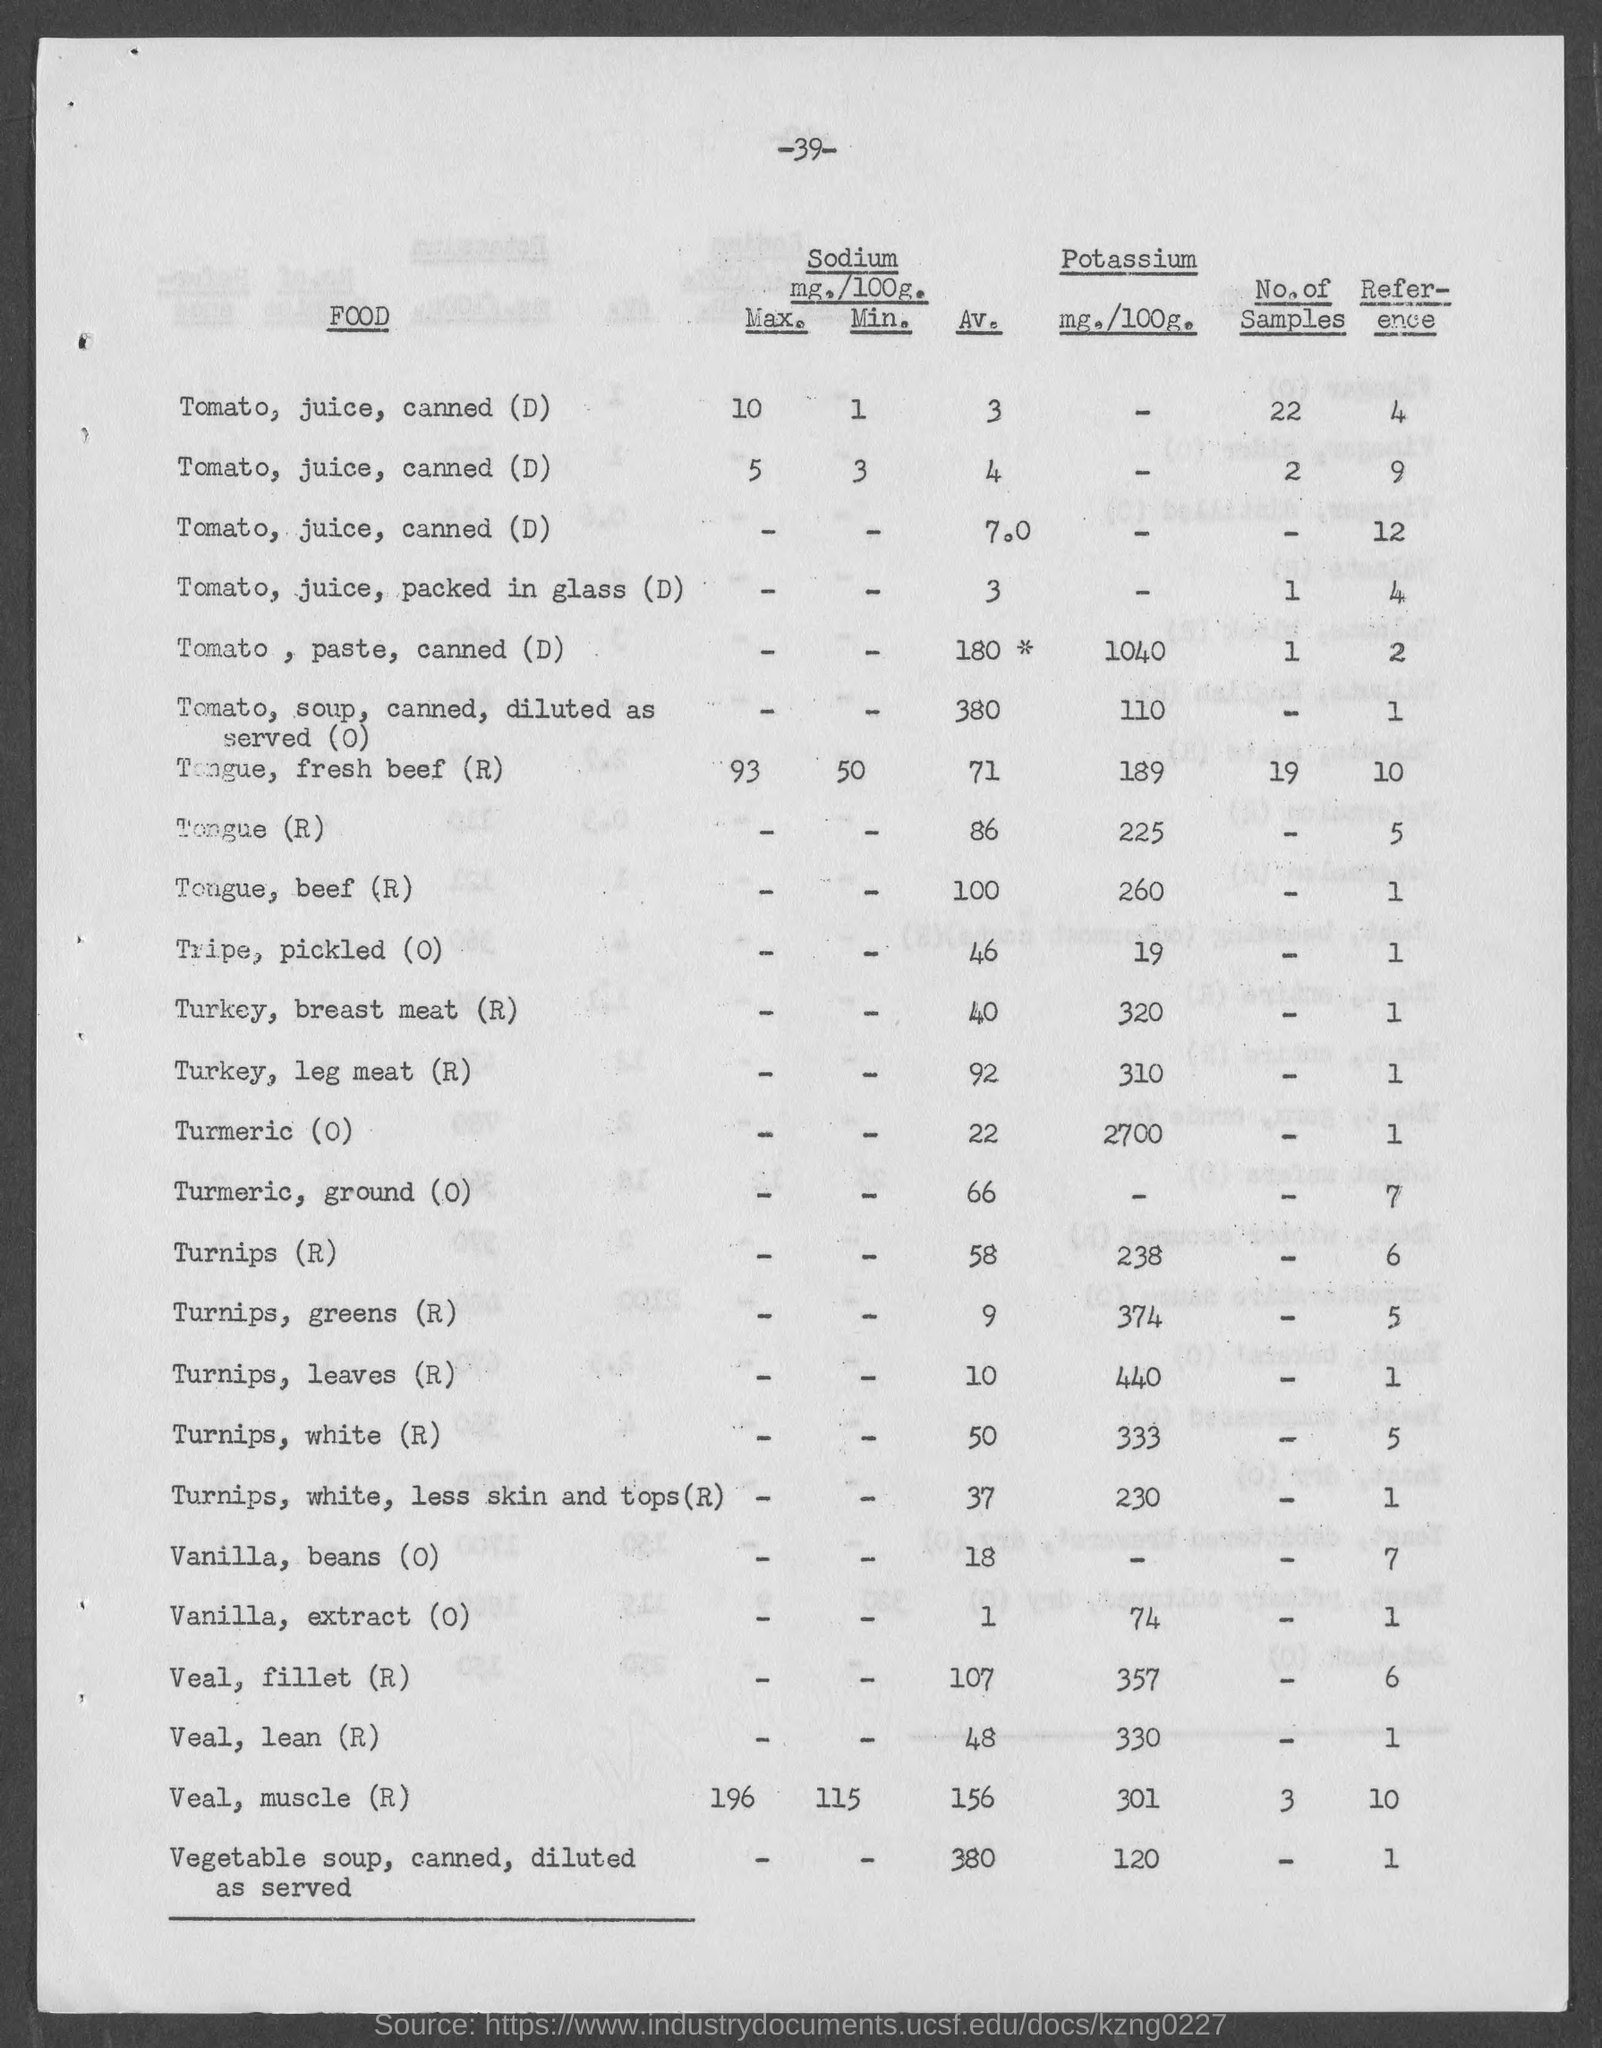What is the amount of potassium present in tomato, paste, canned (d) as mentioned in the given page ? as mentioned in the given page ?
Give a very brief answer. 1040. What is the reference value for tongue(r) as mentioned in the given form ?
Provide a succinct answer. 5. What is the reference value for tongue,beef(r) as mentioned in the given page ?
Make the answer very short. 1. What is the amount of potassium present in veal, lean(r) as mentioned in the given page ?
Offer a terse response. 330. What is the amount of potassium present in veal, muscle(r) as mentioned in the given page ?
Ensure brevity in your answer.  301. What are the no. of samples present for tongue, fresh beef(r) as mentioned in the given page ?
Your answer should be very brief. 19. What is the av. value of veal, fillet (r) as mentioned in the given page ?
Offer a terse response. 107. What is the av. value of vanilla, beans (o) as mentioned in the given page ?
Offer a very short reply. 18. 